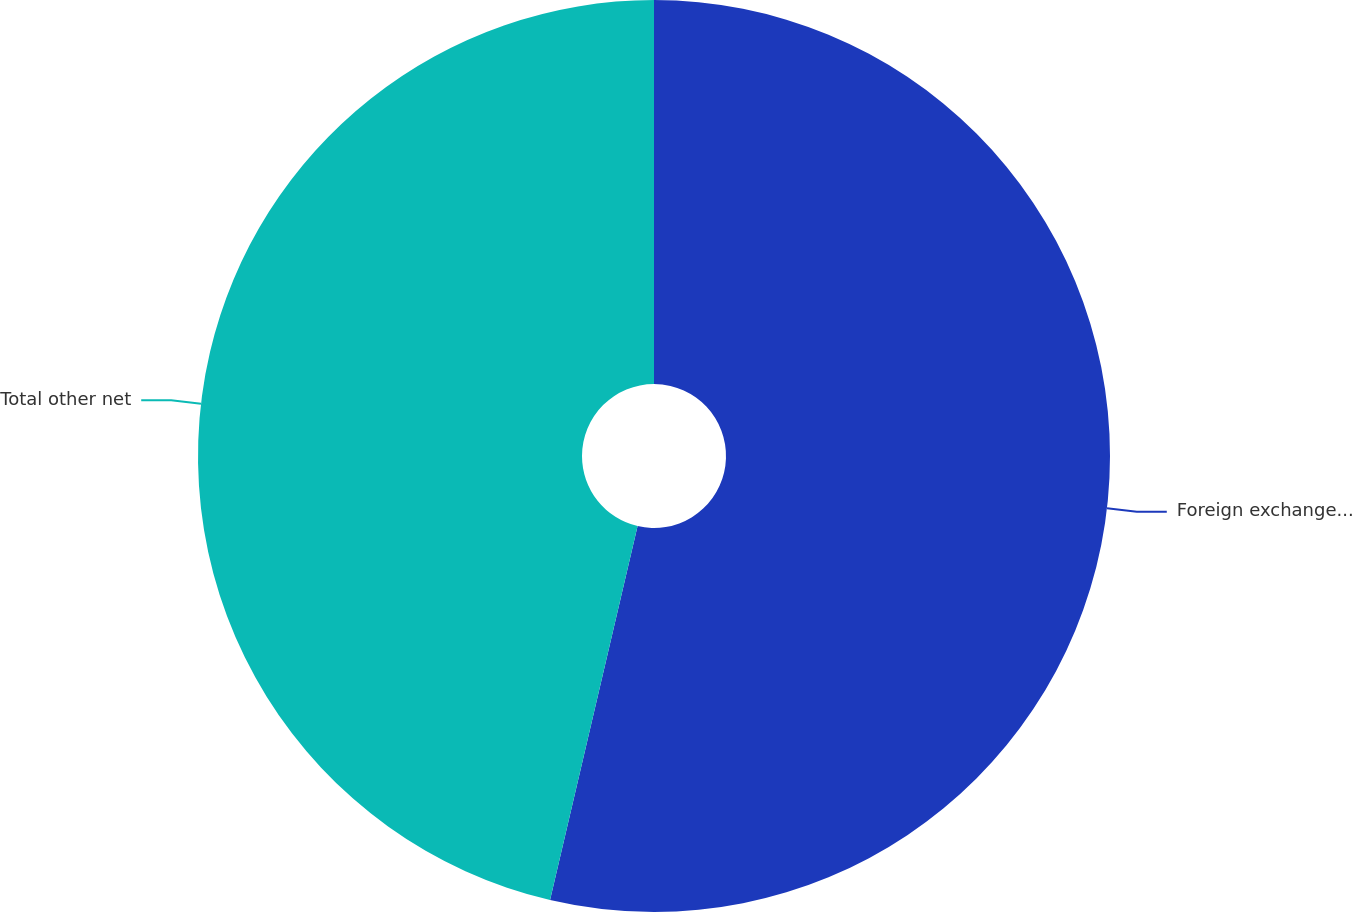Convert chart. <chart><loc_0><loc_0><loc_500><loc_500><pie_chart><fcel>Foreign exchange rate losses<fcel>Total other net<nl><fcel>53.66%<fcel>46.34%<nl></chart> 